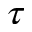Convert formula to latex. <formula><loc_0><loc_0><loc_500><loc_500>\tau</formula> 